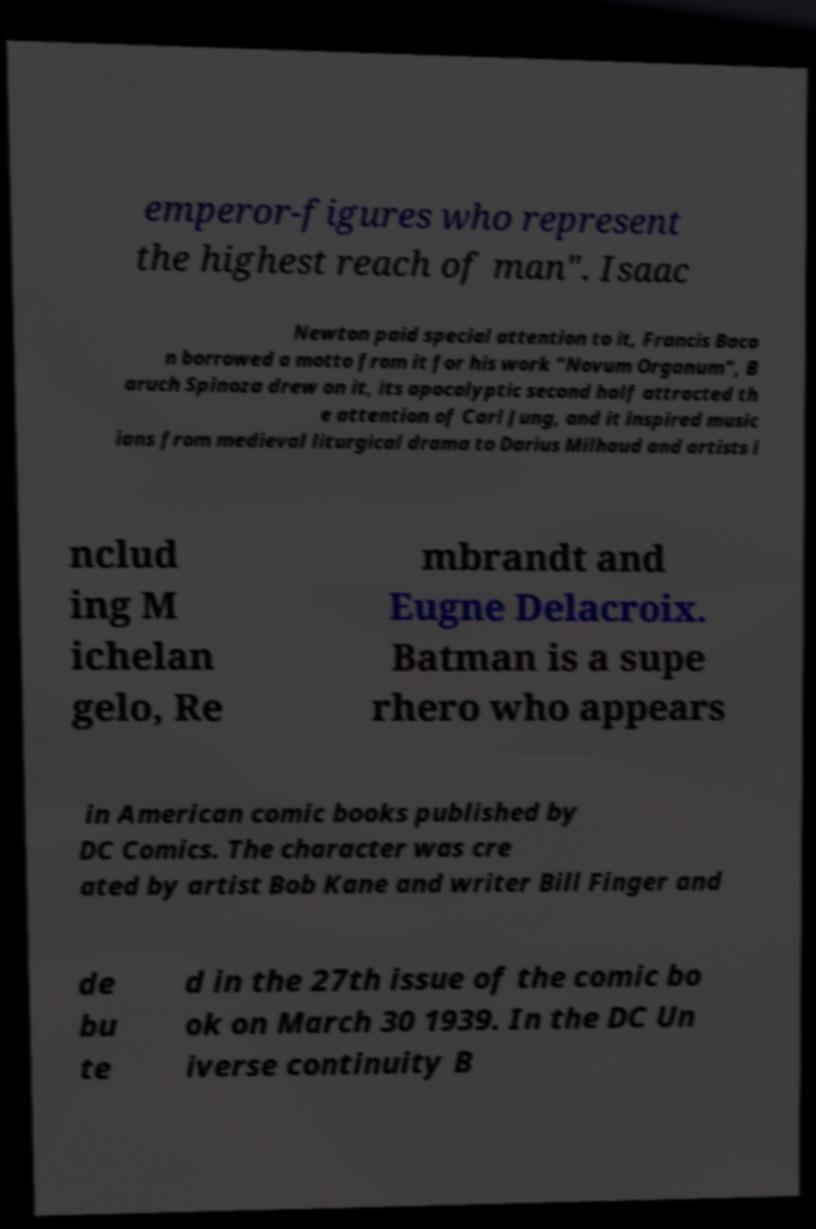Please read and relay the text visible in this image. What does it say? emperor-figures who represent the highest reach of man". Isaac Newton paid special attention to it, Francis Baco n borrowed a motto from it for his work "Novum Organum", B aruch Spinoza drew on it, its apocalyptic second half attracted th e attention of Carl Jung, and it inspired music ians from medieval liturgical drama to Darius Milhaud and artists i nclud ing M ichelan gelo, Re mbrandt and Eugne Delacroix. Batman is a supe rhero who appears in American comic books published by DC Comics. The character was cre ated by artist Bob Kane and writer Bill Finger and de bu te d in the 27th issue of the comic bo ok on March 30 1939. In the DC Un iverse continuity B 